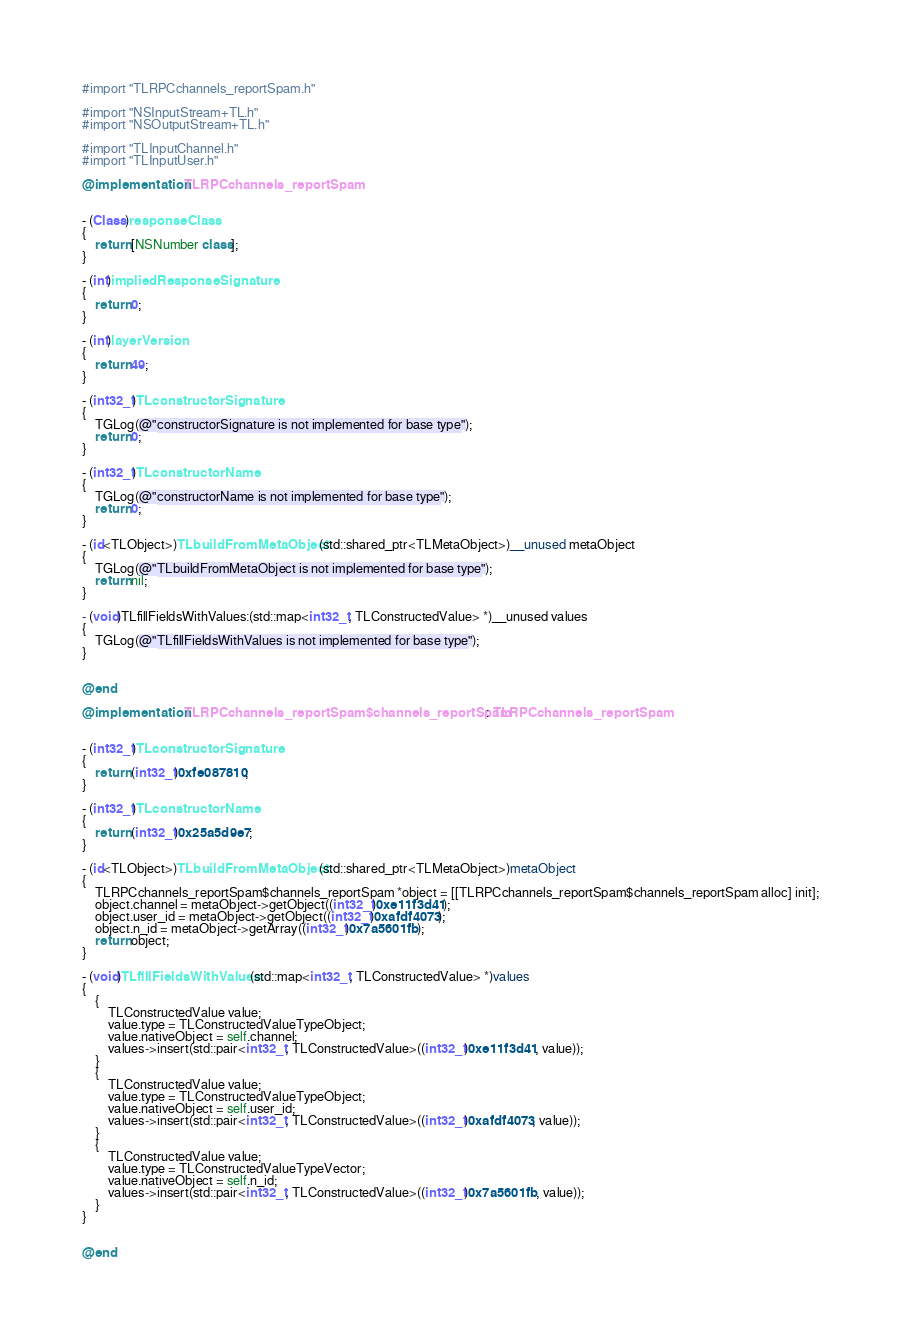Convert code to text. <code><loc_0><loc_0><loc_500><loc_500><_ObjectiveC_>#import "TLRPCchannels_reportSpam.h"

#import "NSInputStream+TL.h"
#import "NSOutputStream+TL.h"

#import "TLInputChannel.h"
#import "TLInputUser.h"

@implementation TLRPCchannels_reportSpam


- (Class)responseClass
{
    return [NSNumber class];
}

- (int)impliedResponseSignature
{
    return 0;
}

- (int)layerVersion
{
    return 49;
}

- (int32_t)TLconstructorSignature
{
    TGLog(@"constructorSignature is not implemented for base type");
    return 0;
}

- (int32_t)TLconstructorName
{
    TGLog(@"constructorName is not implemented for base type");
    return 0;
}

- (id<TLObject>)TLbuildFromMetaObject:(std::shared_ptr<TLMetaObject>)__unused metaObject
{
    TGLog(@"TLbuildFromMetaObject is not implemented for base type");
    return nil;
}

- (void)TLfillFieldsWithValues:(std::map<int32_t, TLConstructedValue> *)__unused values
{
    TGLog(@"TLfillFieldsWithValues is not implemented for base type");
}


@end

@implementation TLRPCchannels_reportSpam$channels_reportSpam : TLRPCchannels_reportSpam


- (int32_t)TLconstructorSignature
{
    return (int32_t)0xfe087810;
}

- (int32_t)TLconstructorName
{
    return (int32_t)0x25a5d9e7;
}

- (id<TLObject>)TLbuildFromMetaObject:(std::shared_ptr<TLMetaObject>)metaObject
{
    TLRPCchannels_reportSpam$channels_reportSpam *object = [[TLRPCchannels_reportSpam$channels_reportSpam alloc] init];
    object.channel = metaObject->getObject((int32_t)0xe11f3d41);
    object.user_id = metaObject->getObject((int32_t)0xafdf4073);
    object.n_id = metaObject->getArray((int32_t)0x7a5601fb);
    return object;
}

- (void)TLfillFieldsWithValues:(std::map<int32_t, TLConstructedValue> *)values
{
    {
        TLConstructedValue value;
        value.type = TLConstructedValueTypeObject;
        value.nativeObject = self.channel;
        values->insert(std::pair<int32_t, TLConstructedValue>((int32_t)0xe11f3d41, value));
    }
    {
        TLConstructedValue value;
        value.type = TLConstructedValueTypeObject;
        value.nativeObject = self.user_id;
        values->insert(std::pair<int32_t, TLConstructedValue>((int32_t)0xafdf4073, value));
    }
    {
        TLConstructedValue value;
        value.type = TLConstructedValueTypeVector;
        value.nativeObject = self.n_id;
        values->insert(std::pair<int32_t, TLConstructedValue>((int32_t)0x7a5601fb, value));
    }
}


@end

</code> 